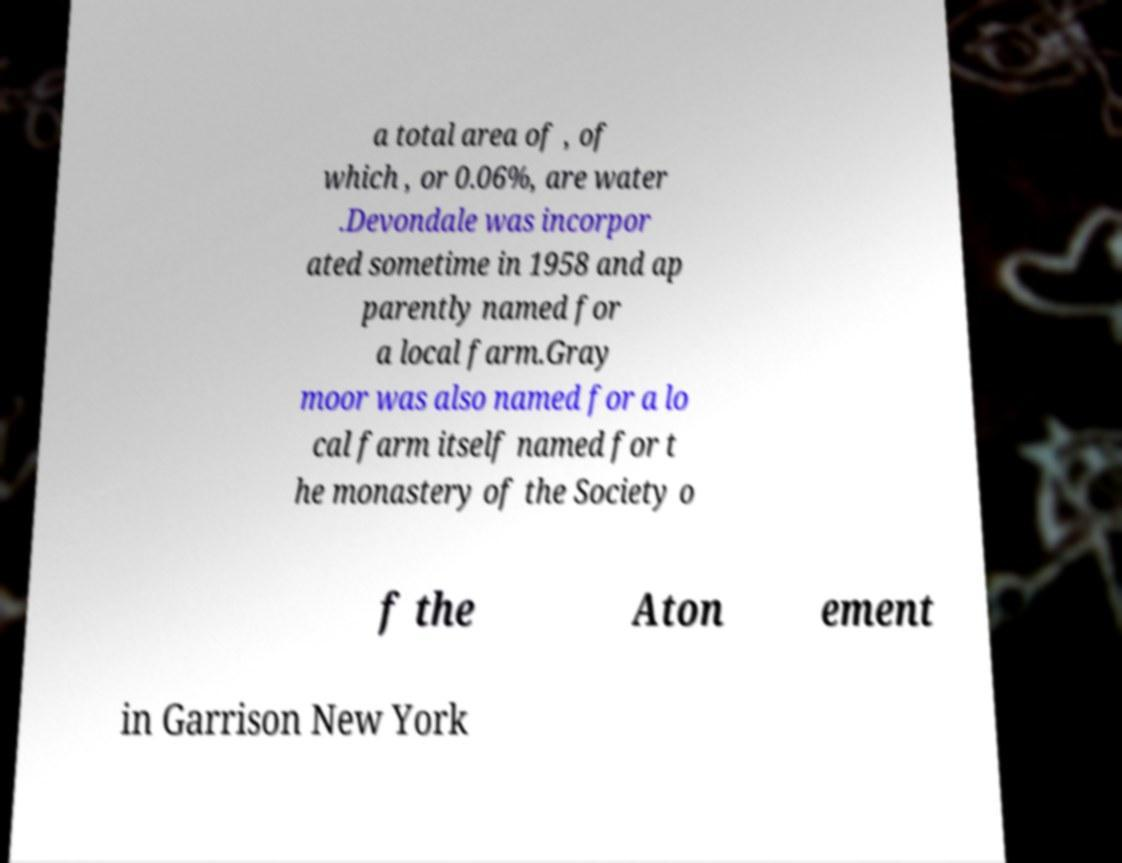Could you extract and type out the text from this image? a total area of , of which , or 0.06%, are water .Devondale was incorpor ated sometime in 1958 and ap parently named for a local farm.Gray moor was also named for a lo cal farm itself named for t he monastery of the Society o f the Aton ement in Garrison New York 